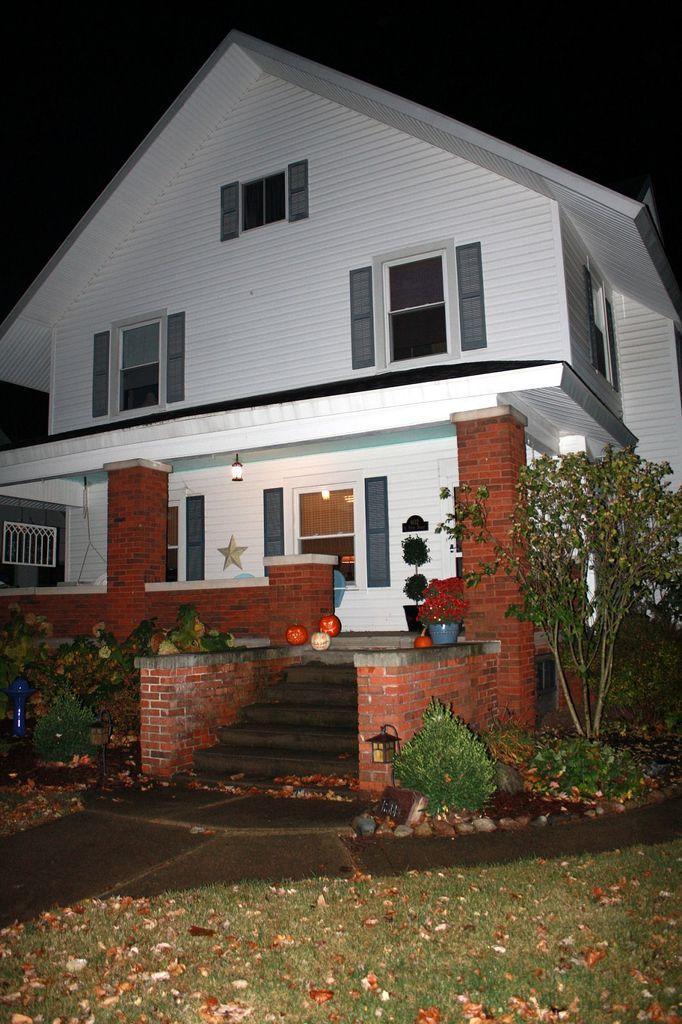Can you describe this image briefly? I can see a white color of house and a star on the wall as part of decoration. I can see few more decorations near the entrance of the house. I can also see few plants and grass in front of the house. 